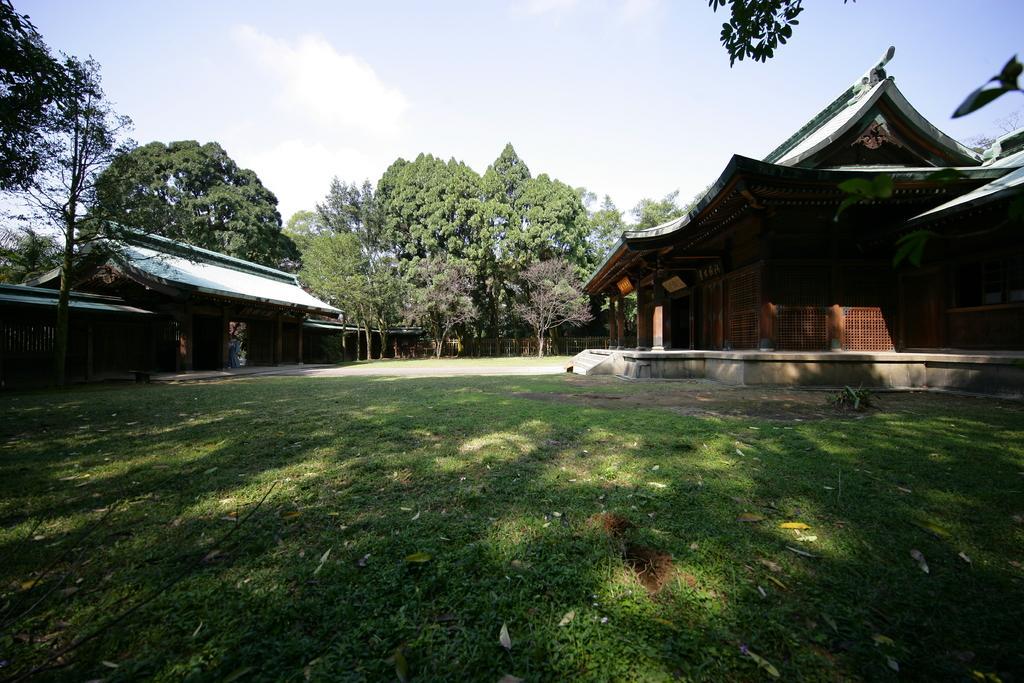Describe this image in one or two sentences. As we can see in the image there is grass, houses, trees and sky. 